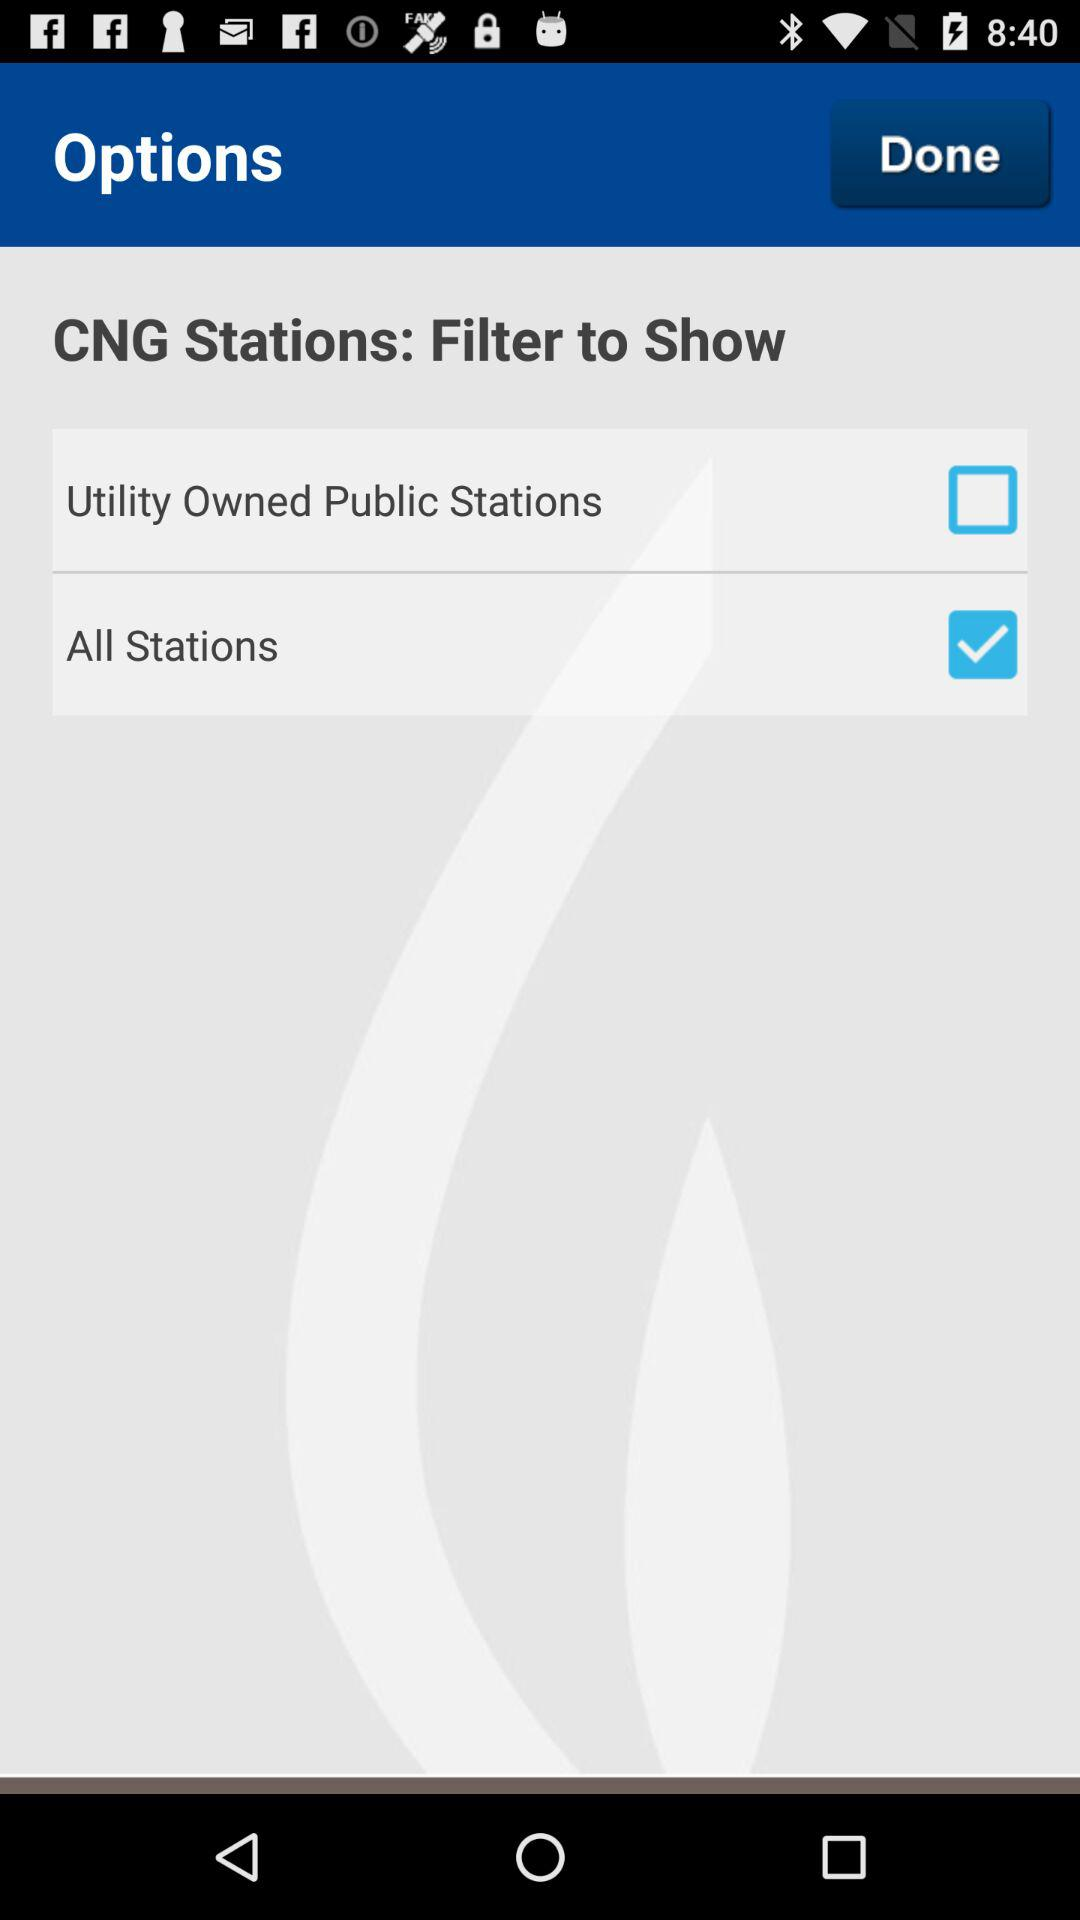What is the current status of "All Stations"? The current status is "on". 